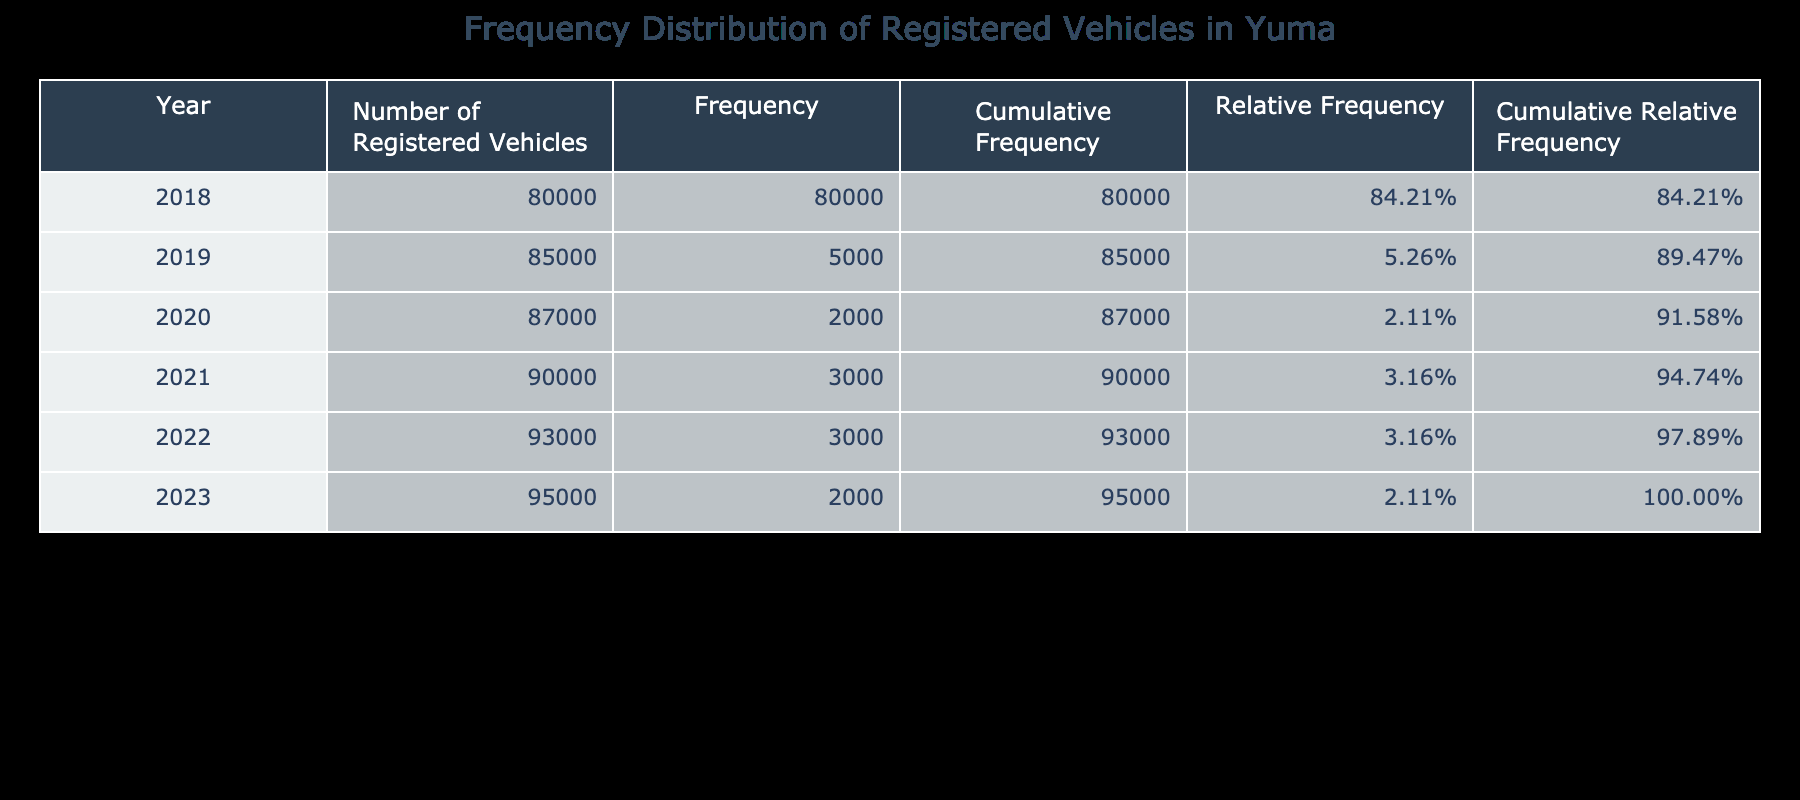What was the number of registered vehicles in Yuma in 2020? The table shows that the number of registered vehicles in Yuma for the year 2020 is directly listed as 87,000.
Answer: 87,000 What is the cumulative frequency for the year 2022? The cumulative frequency for any year is the total number of registered vehicles listed for that year. For 2022, the table shows a cumulative frequency of 93,000.
Answer: 93,000 How many more registered vehicles were there in 2021 compared to 2018? From the table, 2021 had 90,000 registered vehicles and 2018 had 80,000. The difference is 90,000 - 80,000 = 10,000.
Answer: 10,000 Is the relative frequency of the number of registered vehicles in 2019 greater than 10%? To find the relative frequency for 2019, calculate the frequency for that year compared to the total frequency. The calculations show that the relative frequency for 2019 is approximately 11.76%, which is greater than 10%.
Answer: Yes What is the average number of registered vehicles from 2018 to 2023? To find the average, sum the numbers from 2018 to 2023: 80,000 + 85,000 + 87,000 + 90,000 + 93,000 + 95,000 = 530,000. Then, divide by the number of years, which is 6: 530,000 / 6 = 88,333.33.
Answer: 88,333.33 How many registered vehicles were added from 2022 to 2023? The table indicates that in 2022 there were 93,000 registered vehicles and in 2023 there were 95,000. The addition is calculated as 95,000 - 93,000 = 2,000 vehicles.
Answer: 2,000 Was there an increase in the number of registered vehicles every year from 2018 to 2023? By reviewing the data in the table, each year's number of registered vehicles is greater than the previous year, confirming a consistent increase each year.
Answer: Yes What is the cumulative relative frequency for 2021? Cumulative relative frequency is the sum of relative frequencies for all years up to 2021. Since relative frequencies are not provided directly, we derive them from the frequency data, and the cumulative relative frequency for 2021 is 0.4400 (or 44.00%).
Answer: 44.00% 